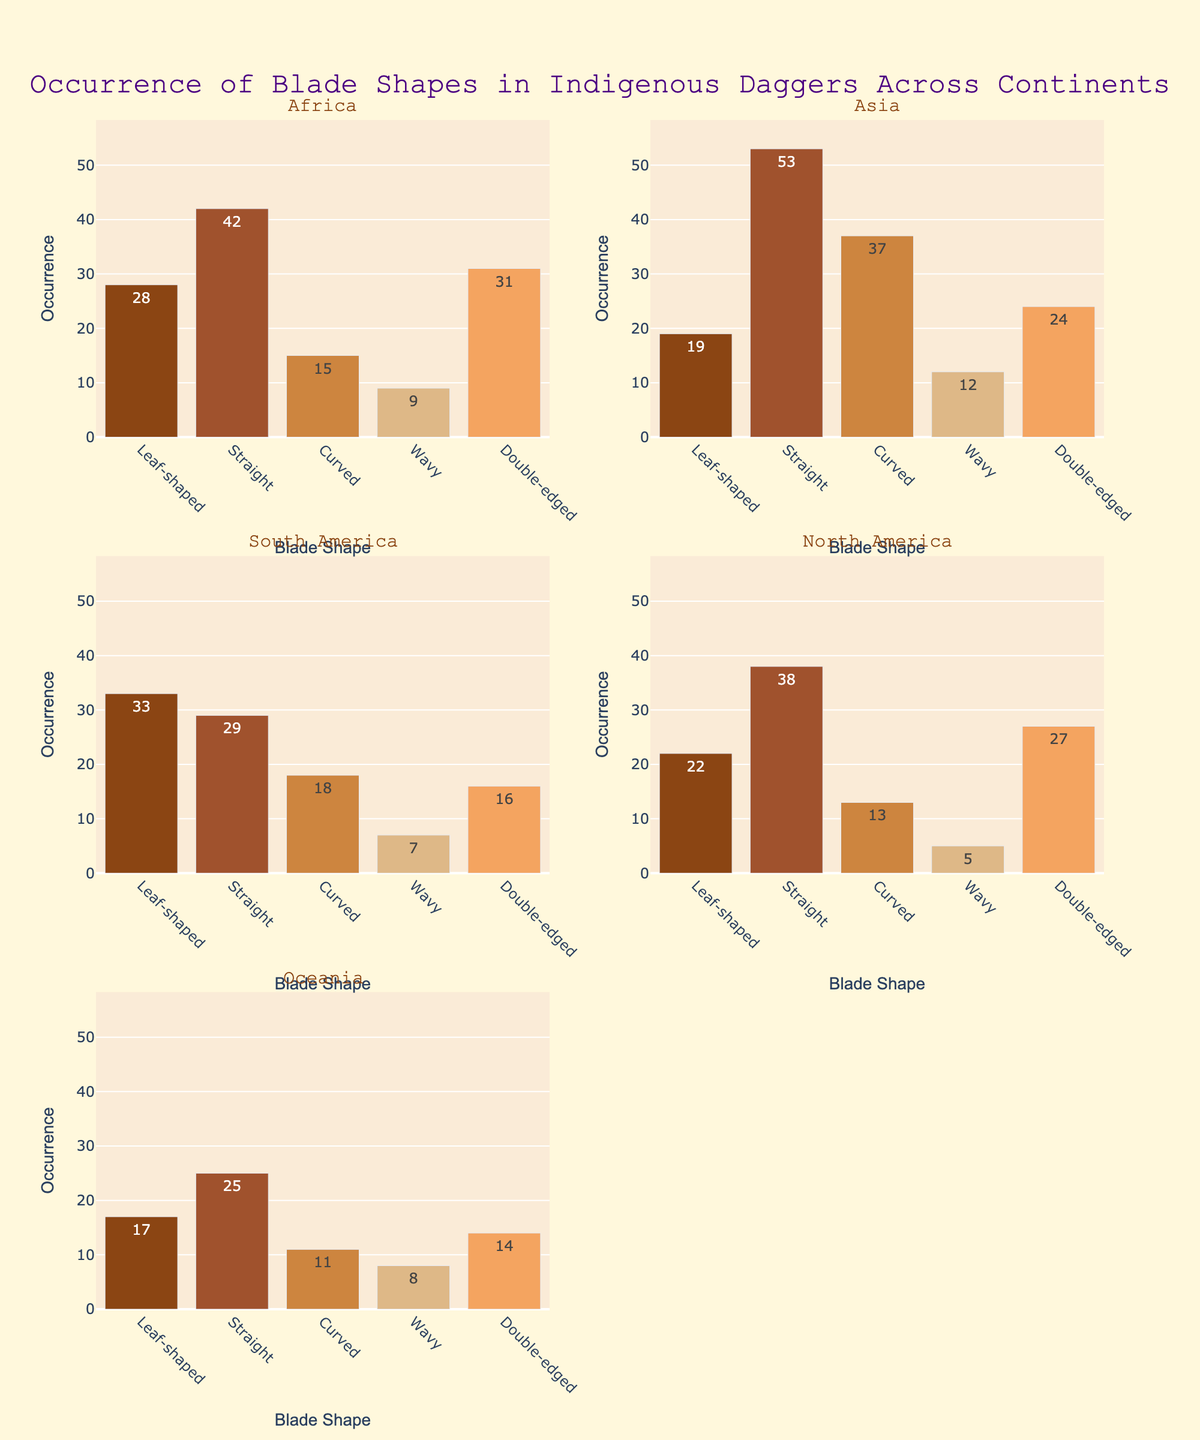What's the title of the plot? The title of the plot is usually located at the top center and describes the content of the visualization. In this case, it reads "Occurrence of Blade Shapes in Indigenous Daggers Across Continents".
Answer: Occurrence of Blade Shapes in Indigenous Daggers Across Continents Which blade shape has the highest occurrence in Asia? By looking at the subplot for Asia, you can see that the tallest bar corresponds to the 'Straight' blade shape.
Answer: Straight What is the total occurrence of 'Leaf-shaped' blades across all continents? Sum the occurrences of 'Leaf-shaped' blades for all continents: 28 (Africa) + 19 (Asia) + 33 (South America) + 22 (North America) + 17 (Oceania) = 119.
Answer: 119 Which continent has the lowest occurrence of 'Wavy' blades? Compare the heights of the 'Wavy' blade shape bars across all subplots. North America's 'Wavy' blade shape has the smallest bar, indicating the lowest occurrence.
Answer: North America What is the sum of occurrences for 'Double-edged' blades in Africa and Oceania? Add the occurrences of 'Double-edged' blades in Africa and Oceania: 31 (Africa) + 14 (Oceania) = 45.
Answer: 45 Which continent has the smallest overall number of blade shape occurrences? Add up the occurrences of all blade shapes per continent and compare. Oceania has: 17 (Leaf-shaped) + 25 (Straight) + 11 (Curved) + 8 (Wavy) + 14 (Double-edged) = 75, which is the smallest total occurrence.
Answer: Oceania Which two blade shapes in South America combined represent the majority of occurrences? In the South America subplot, 'Leaf-shaped' and 'Straight' blades have the tallest bars with occurrences of 33 and 29 respectively. Together, they count for 33 + 29 = 62 occurrences out of the total 103, which is more than half.
Answer: Leaf-shaped and Straight How many blade shapes in each continent have an occurrence greater than 20? Count the bars taller than 20 in each subplot: Africa (3 - Leaf-shaped, Straight, Double-edged), Asia (3 - Straight, Curved, Double-edged), South America (2 - Leaf-shaped, Straight), North America (2 - Straight, Double-edged), Oceania (1 - Straight).
Answer: Africa: 3; Asia: 3; South America: 2; North America: 2; Oceania: 1 Which blade shape is most equally distributed across continents, considering similar occurrences? The most equally distributed blade shape has the least variation in heights across all subplots. 'Double-edged' blades have occurrences of 31 (Africa), 24 (Asia), 16 (South America), 27 (North America), and 14 (Oceania), with relatively close values when compared to other blade shapes.
Answer: Double-edged 